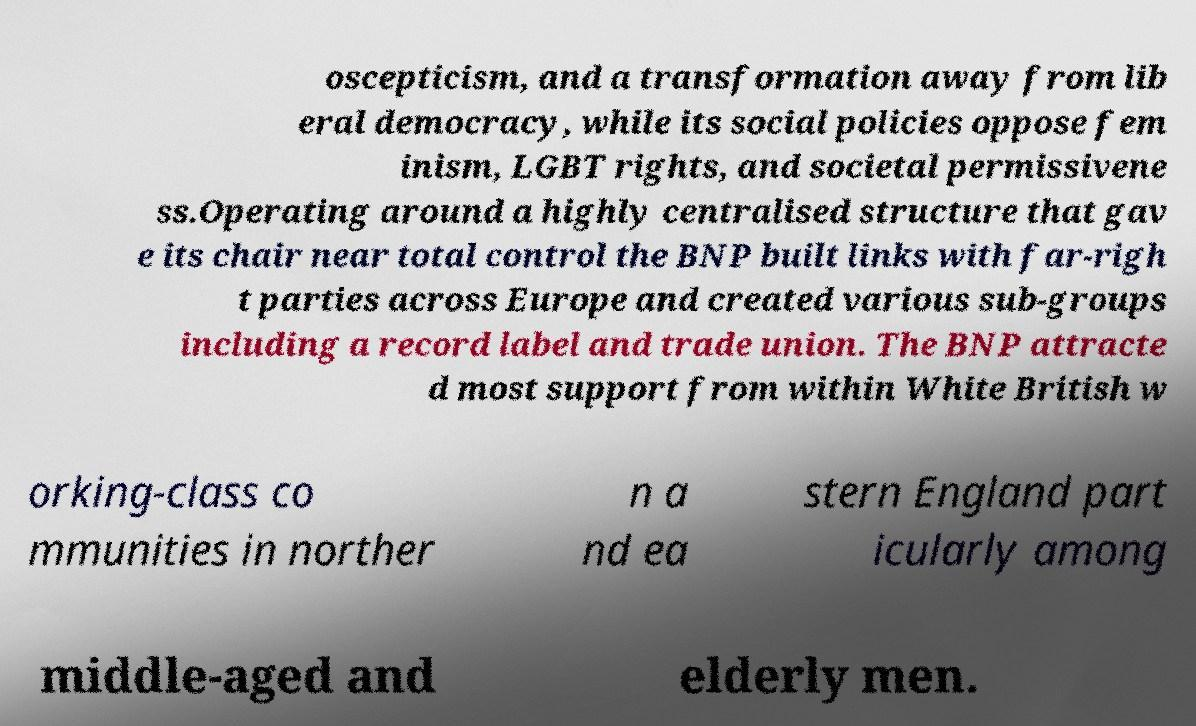Please identify and transcribe the text found in this image. oscepticism, and a transformation away from lib eral democracy, while its social policies oppose fem inism, LGBT rights, and societal permissivene ss.Operating around a highly centralised structure that gav e its chair near total control the BNP built links with far-righ t parties across Europe and created various sub-groups including a record label and trade union. The BNP attracte d most support from within White British w orking-class co mmunities in norther n a nd ea stern England part icularly among middle-aged and elderly men. 